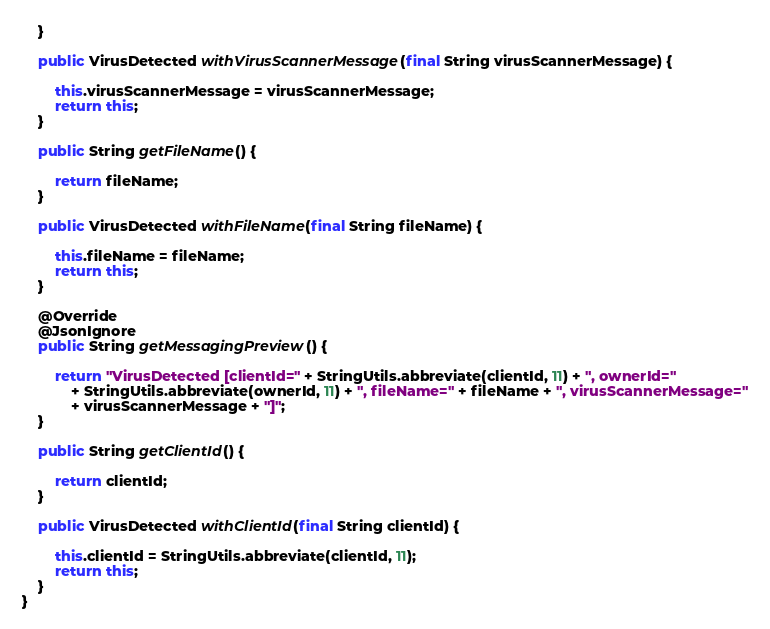Convert code to text. <code><loc_0><loc_0><loc_500><loc_500><_Java_>	}

	public VirusDetected withVirusScannerMessage(final String virusScannerMessage) {

		this.virusScannerMessage = virusScannerMessage;
		return this;
	}

	public String getFileName() {

		return fileName;
	}

	public VirusDetected withFileName(final String fileName) {

		this.fileName = fileName;
		return this;
	}

	@Override
	@JsonIgnore
	public String getMessagingPreview() {

		return "VirusDetected [clientId=" + StringUtils.abbreviate(clientId, 11) + ", ownerId="
			+ StringUtils.abbreviate(ownerId, 11) + ", fileName=" + fileName + ", virusScannerMessage="
			+ virusScannerMessage + "]";
	}

	public String getClientId() {

		return clientId;
	}

	public VirusDetected withClientId(final String clientId) {

		this.clientId = StringUtils.abbreviate(clientId, 11);
		return this;
	}
}
</code> 